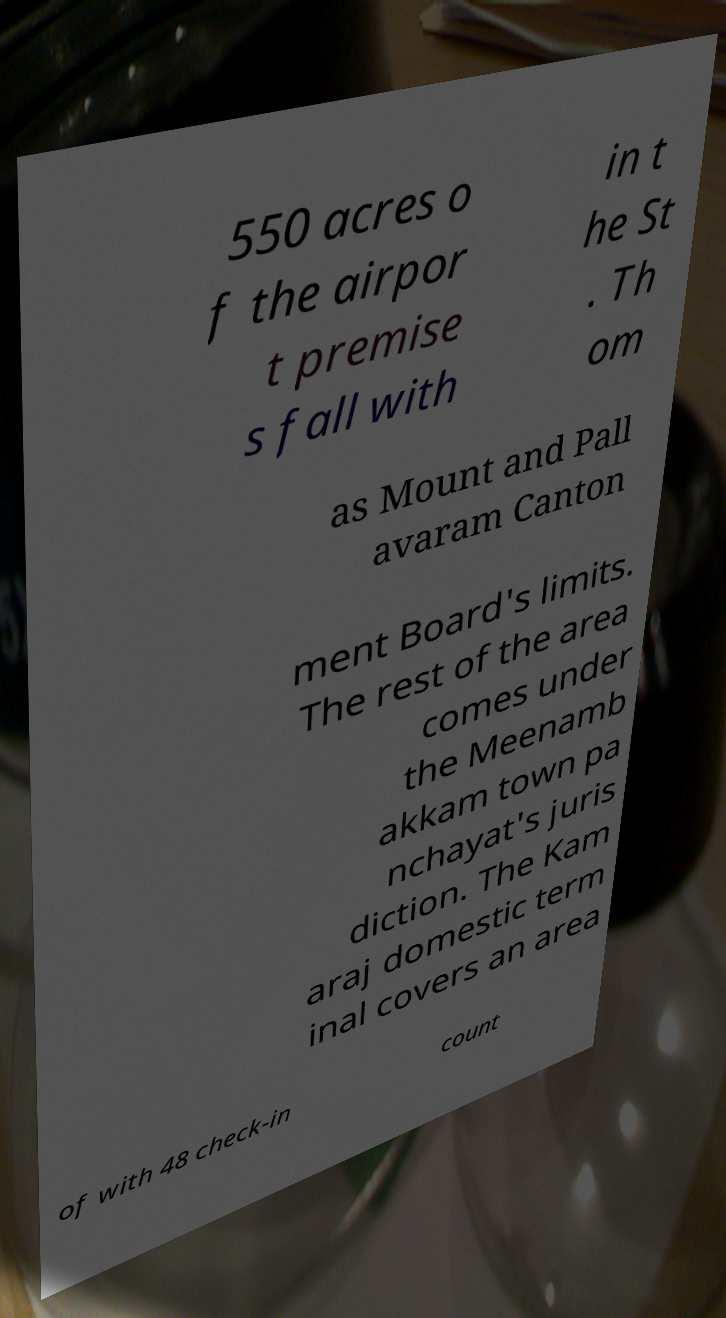Can you read and provide the text displayed in the image?This photo seems to have some interesting text. Can you extract and type it out for me? 550 acres o f the airpor t premise s fall with in t he St . Th om as Mount and Pall avaram Canton ment Board's limits. The rest of the area comes under the Meenamb akkam town pa nchayat's juris diction. The Kam araj domestic term inal covers an area of with 48 check-in count 